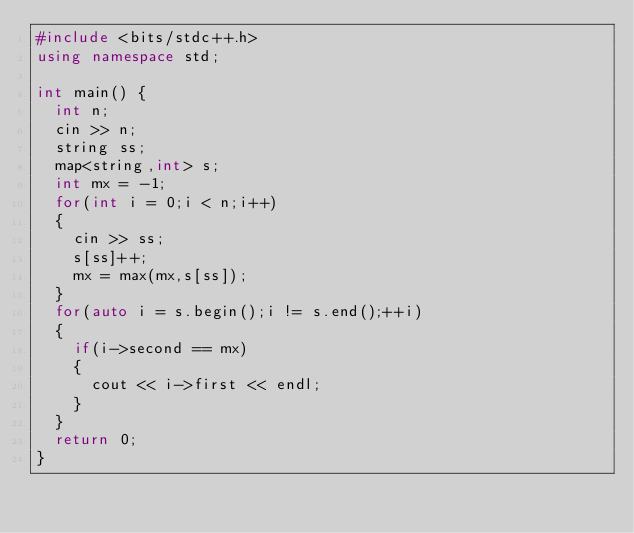<code> <loc_0><loc_0><loc_500><loc_500><_C++_>#include <bits/stdc++.h>
using namespace std;

int main() {
	int n;
	cin >> n;
	string ss;
	map<string,int> s;
	int mx = -1;
	for(int i = 0;i < n;i++)
	{
		cin >> ss;
		s[ss]++;
		mx = max(mx,s[ss]);
	}
	for(auto i = s.begin();i != s.end();++i)
	{
		if(i->second == mx)
		{
			cout << i->first << endl;
		}
	}
	return 0;
}
</code> 